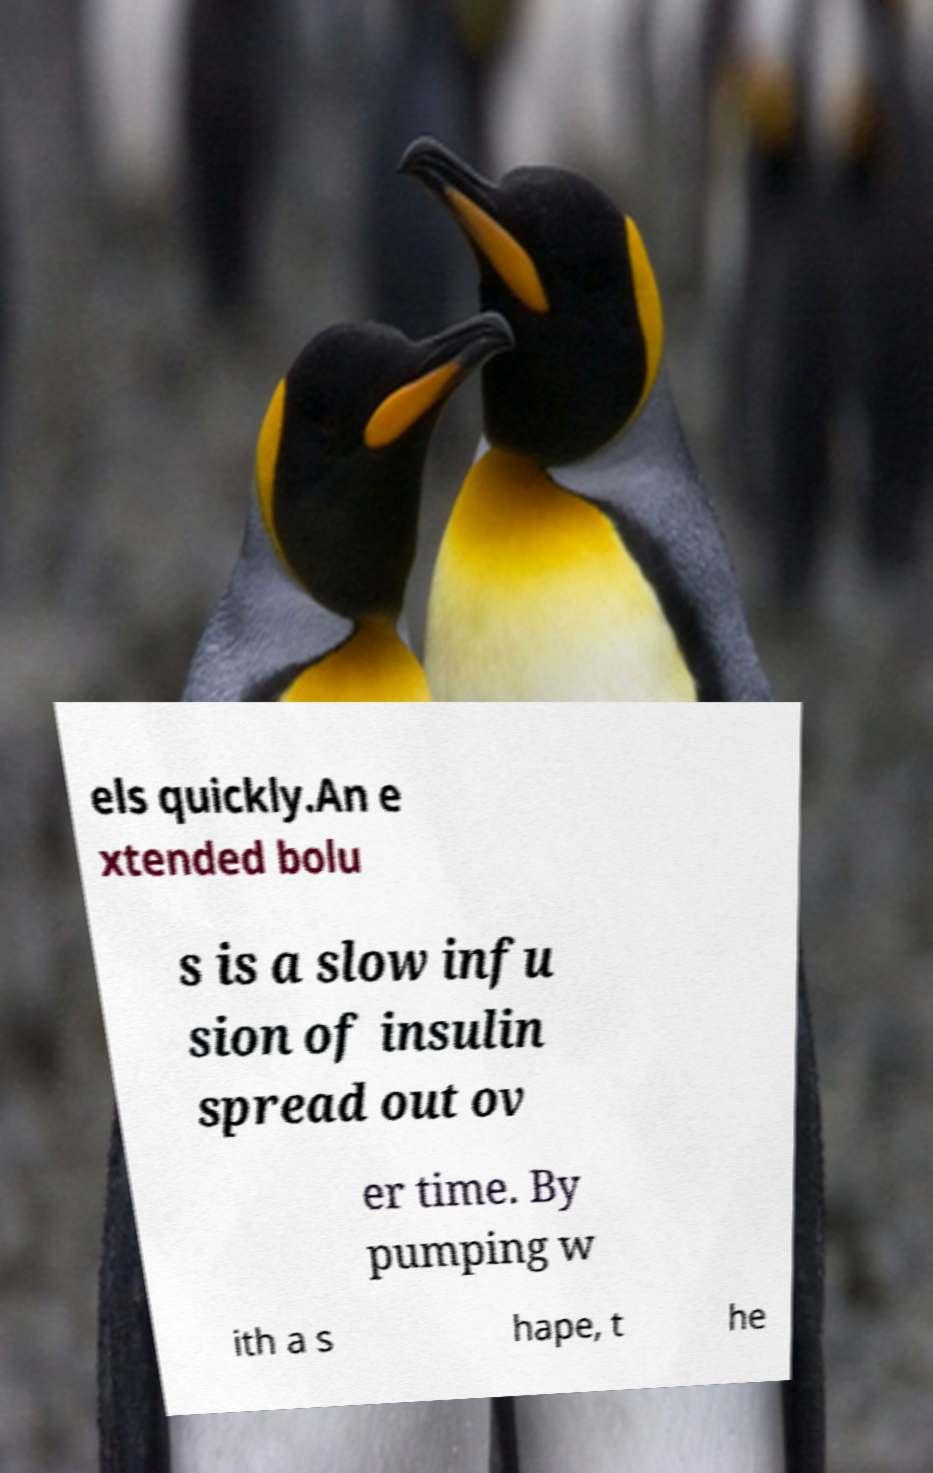Please read and relay the text visible in this image. What does it say? els quickly.An e xtended bolu s is a slow infu sion of insulin spread out ov er time. By pumping w ith a s hape, t he 